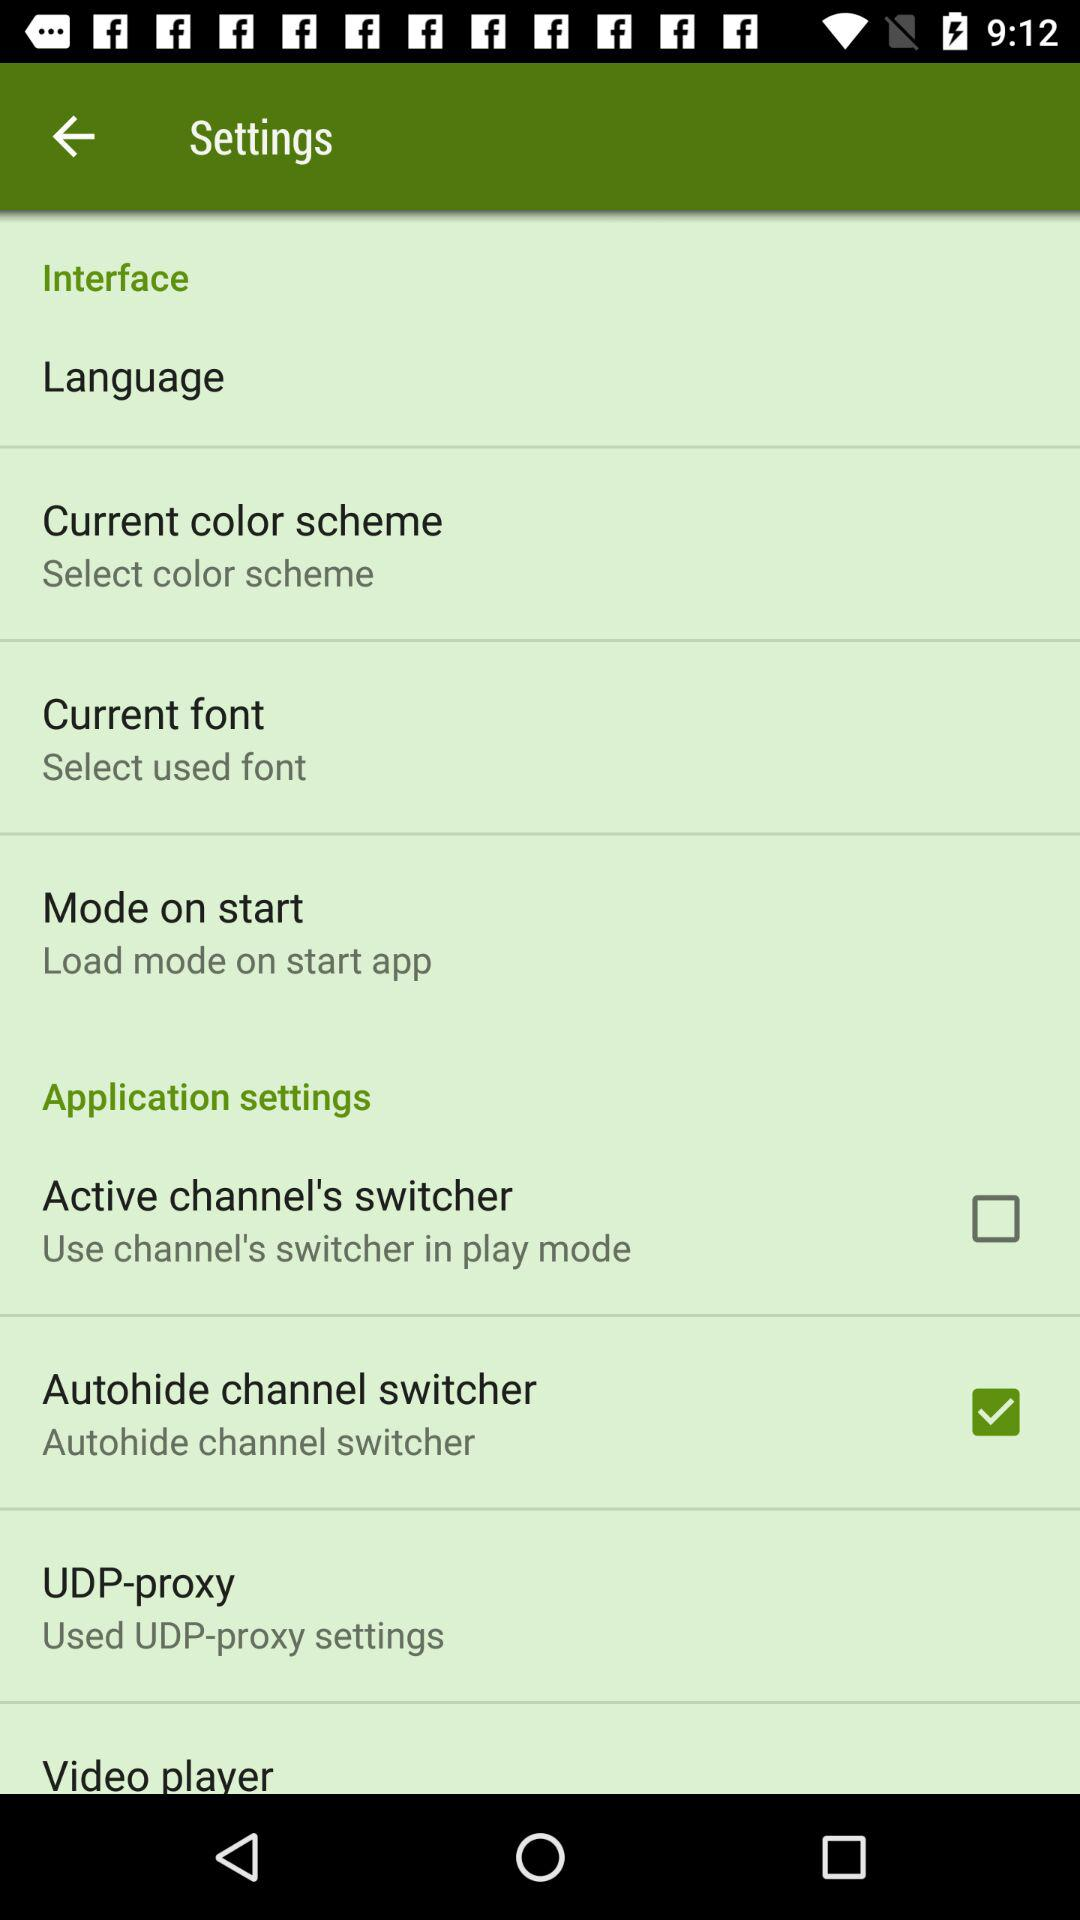What is the status of "Autohide channel switcher"? The status is "on". 